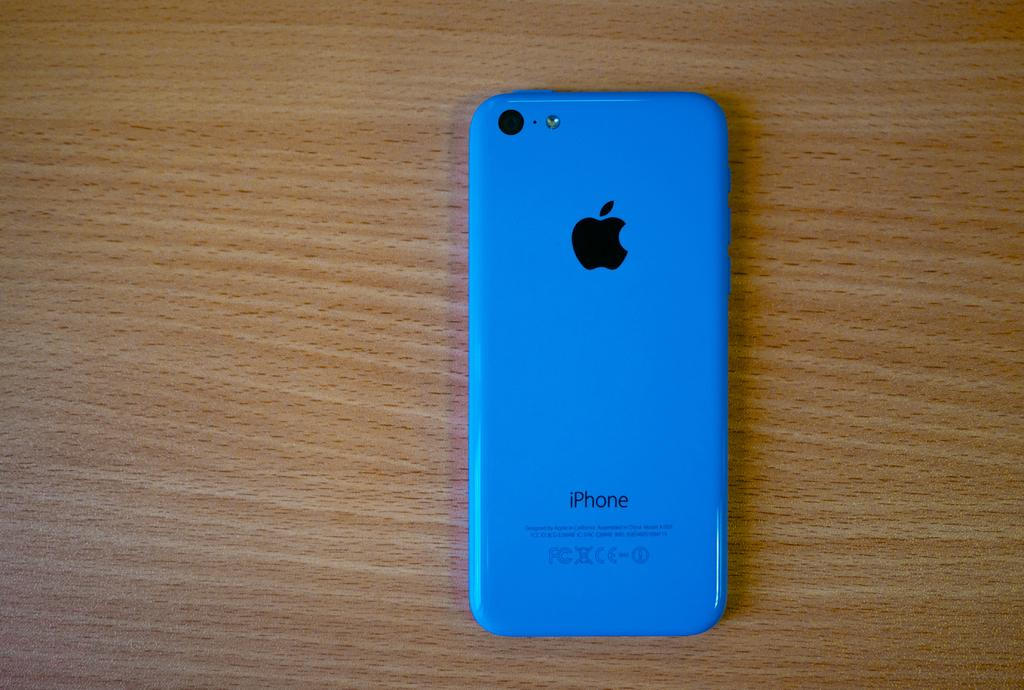<image>
Describe the image concisely. A blue iPhone sits face down on a wood table. 